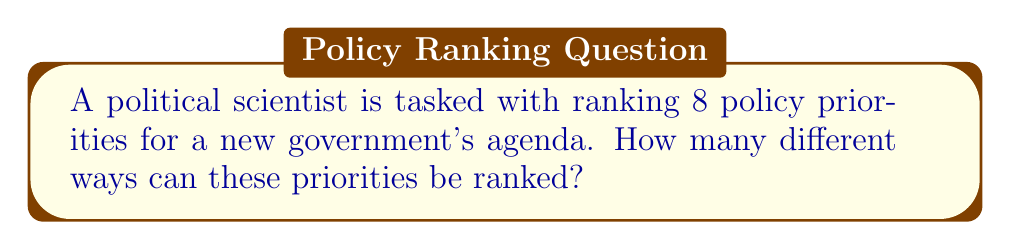Can you solve this math problem? To solve this problem, we need to understand that this is a permutation question. We are arranging all 8 policy priorities in a specific order, and the order matters.

1) In permutation problems where all items are used and order matters, we use the factorial formula:

   $n!$ where $n$ is the number of items

2) In this case, we have 8 policy priorities, so $n = 8$

3) Therefore, the number of ways to rank these priorities is:

   $8! = 8 \times 7 \times 6 \times 5 \times 4 \times 3 \times 2 \times 1$

4) Let's calculate this:
   
   $8! = 40,320$

This means there are 40,320 different ways to rank these 8 policy priorities.

For a political scientist, this large number underscores the complexity of priority-setting in policy agendas and the numerous possible configurations that need to be considered in political analysis.
Answer: $40,320$ 